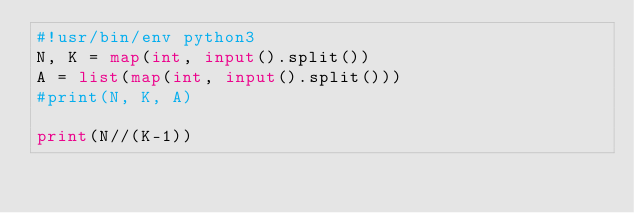Convert code to text. <code><loc_0><loc_0><loc_500><loc_500><_Python_>#!usr/bin/env python3
N, K = map(int, input().split())    
A = list(map(int, input().split()))
#print(N, K, A)

print(N//(K-1))</code> 